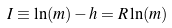<formula> <loc_0><loc_0><loc_500><loc_500>I \equiv \ln ( m ) - h = R \ln ( m )</formula> 